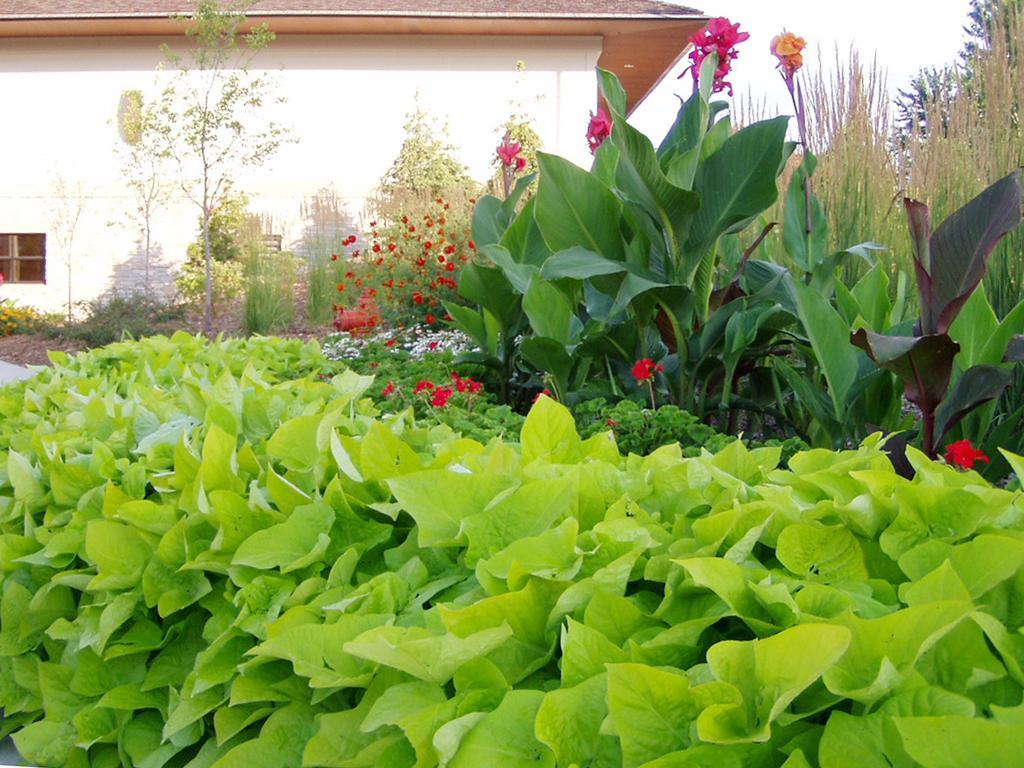Can you describe this image briefly? In this image there are plants, tree, in the background there is a building. 